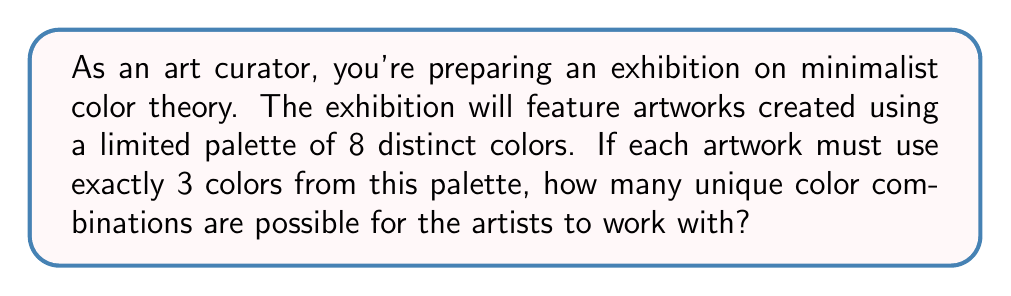What is the answer to this math problem? To solve this problem, we need to use the concept of combinations from probability theory. We are selecting 3 colors from a set of 8 colors, where the order doesn't matter (since we're just interested in the combination of colors, not their arrangement).

This scenario can be represented by the combination formula:

$$ C(n,r) = \frac{n!}{r!(n-r)!} $$

Where:
$n$ is the total number of items to choose from (in this case, 8 colors)
$r$ is the number of items being chosen (in this case, 3 colors)

Plugging in our values:

$$ C(8,3) = \frac{8!}{3!(8-3)!} = \frac{8!}{3!5!} $$

Now, let's calculate this step by step:

1) $8! = 8 \times 7 \times 6 \times 5!$
2) $3! = 3 \times 2 \times 1 = 6$

So our equation becomes:

$$ \frac{8 \times 7 \times 6 \times 5!}{6 \times 5!} $$

The $5!$ cancels out in the numerator and denominator:

$$ \frac{8 \times 7 \times 6}{6} $$

$$ = 8 \times 7 = 56 $$

Therefore, there are 56 unique color combinations possible.
Answer: 56 unique color combinations 